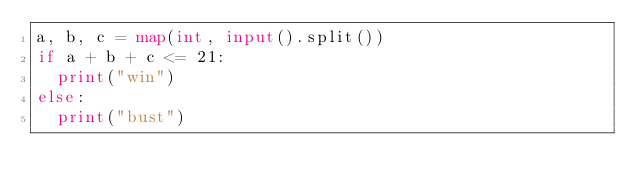<code> <loc_0><loc_0><loc_500><loc_500><_Python_>a, b, c = map(int, input().split())
if a + b + c <= 21:
  print("win")
else:
  print("bust")</code> 